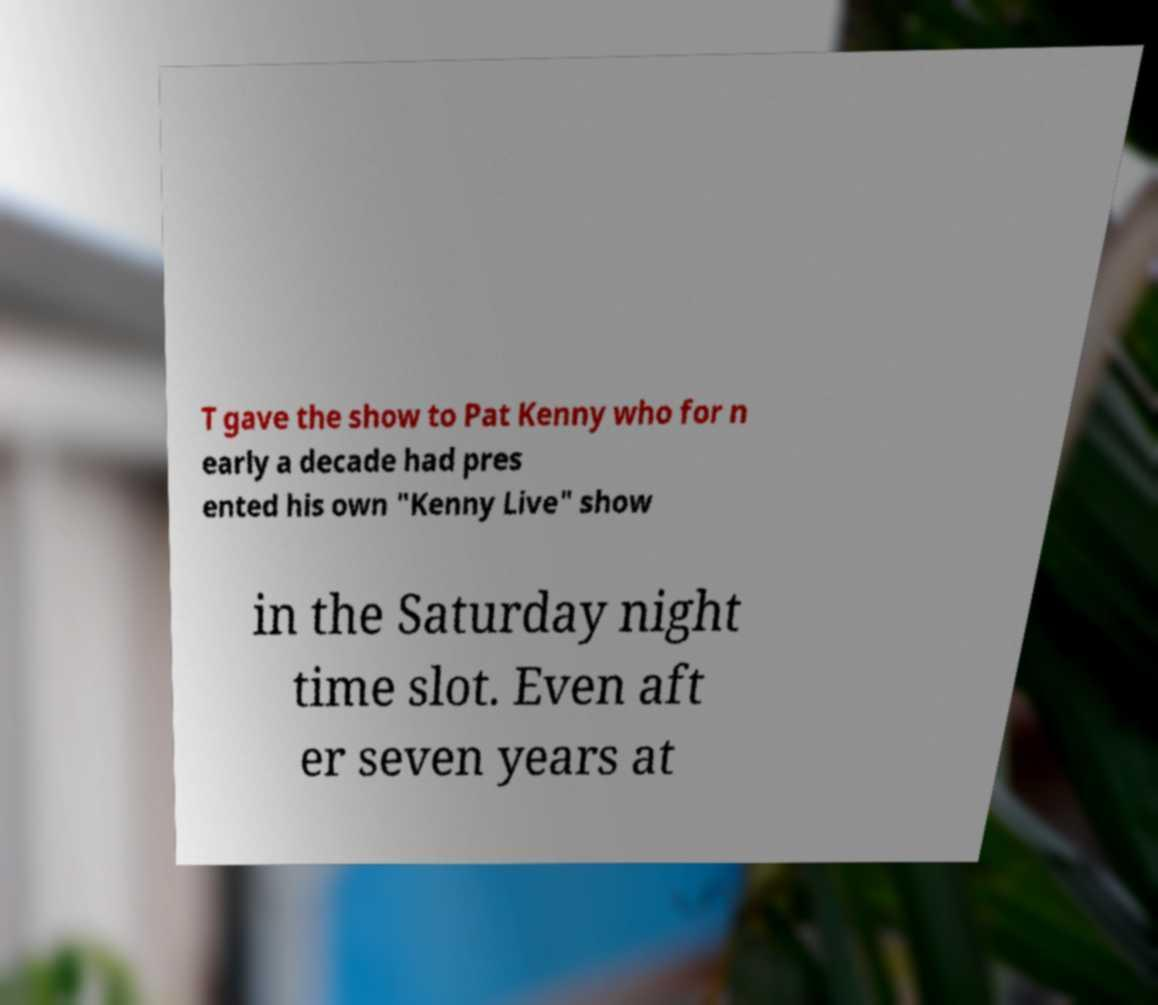I need the written content from this picture converted into text. Can you do that? T gave the show to Pat Kenny who for n early a decade had pres ented his own "Kenny Live" show in the Saturday night time slot. Even aft er seven years at 